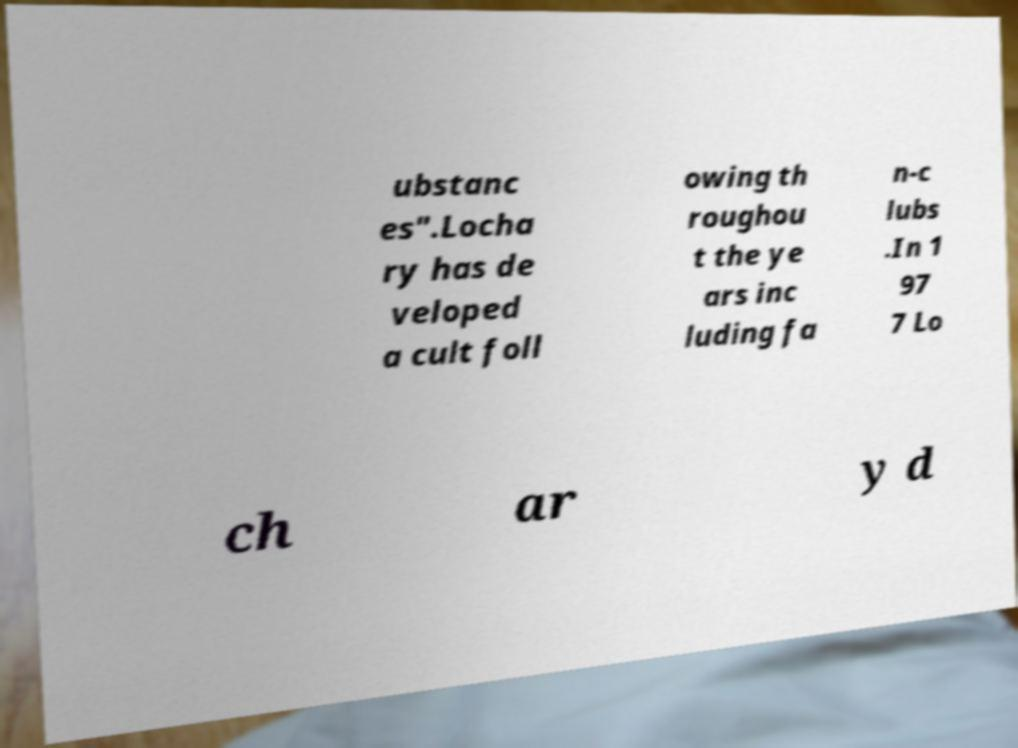Can you accurately transcribe the text from the provided image for me? ubstanc es".Locha ry has de veloped a cult foll owing th roughou t the ye ars inc luding fa n-c lubs .In 1 97 7 Lo ch ar y d 